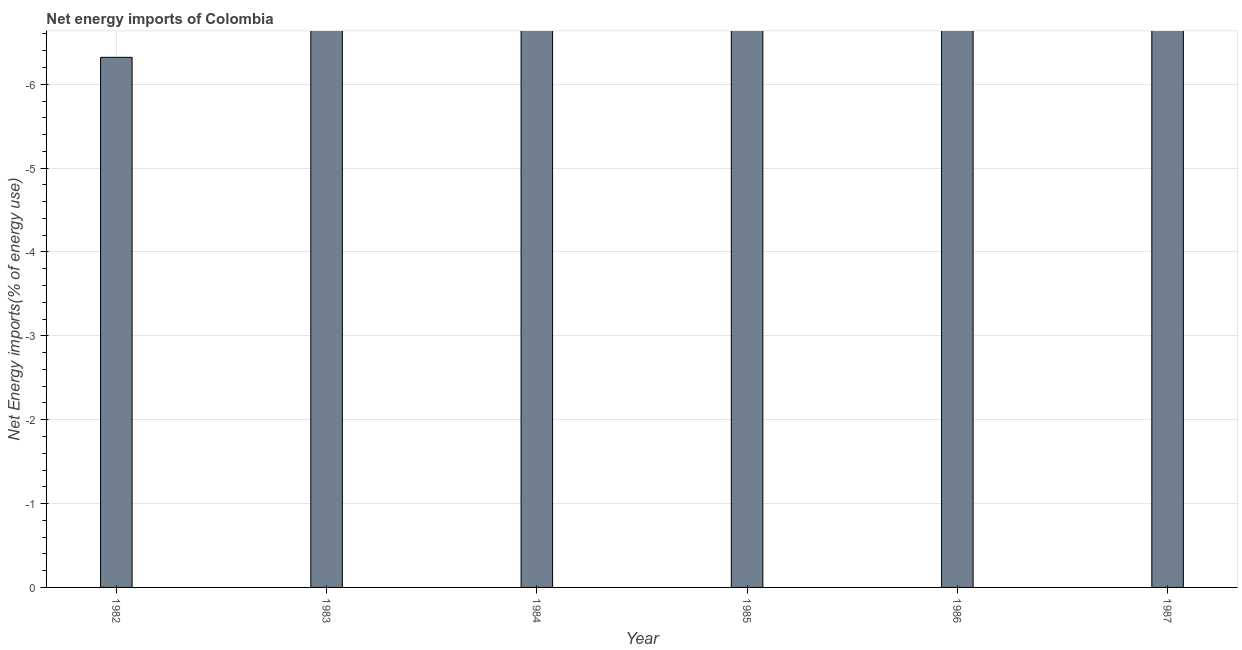Does the graph contain any zero values?
Provide a succinct answer. Yes. Does the graph contain grids?
Ensure brevity in your answer.  Yes. What is the title of the graph?
Provide a succinct answer. Net energy imports of Colombia. What is the label or title of the X-axis?
Provide a short and direct response. Year. What is the label or title of the Y-axis?
Make the answer very short. Net Energy imports(% of energy use). What is the energy imports in 1982?
Provide a short and direct response. 0. What is the average energy imports per year?
Your answer should be compact. 0. What is the median energy imports?
Give a very brief answer. 0. In how many years, is the energy imports greater than -6.6 %?
Provide a succinct answer. 1. In how many years, is the energy imports greater than the average energy imports taken over all years?
Make the answer very short. 0. How many years are there in the graph?
Give a very brief answer. 6. What is the Net Energy imports(% of energy use) in 1985?
Your answer should be compact. 0. What is the Net Energy imports(% of energy use) in 1986?
Make the answer very short. 0. What is the Net Energy imports(% of energy use) of 1987?
Your response must be concise. 0. 